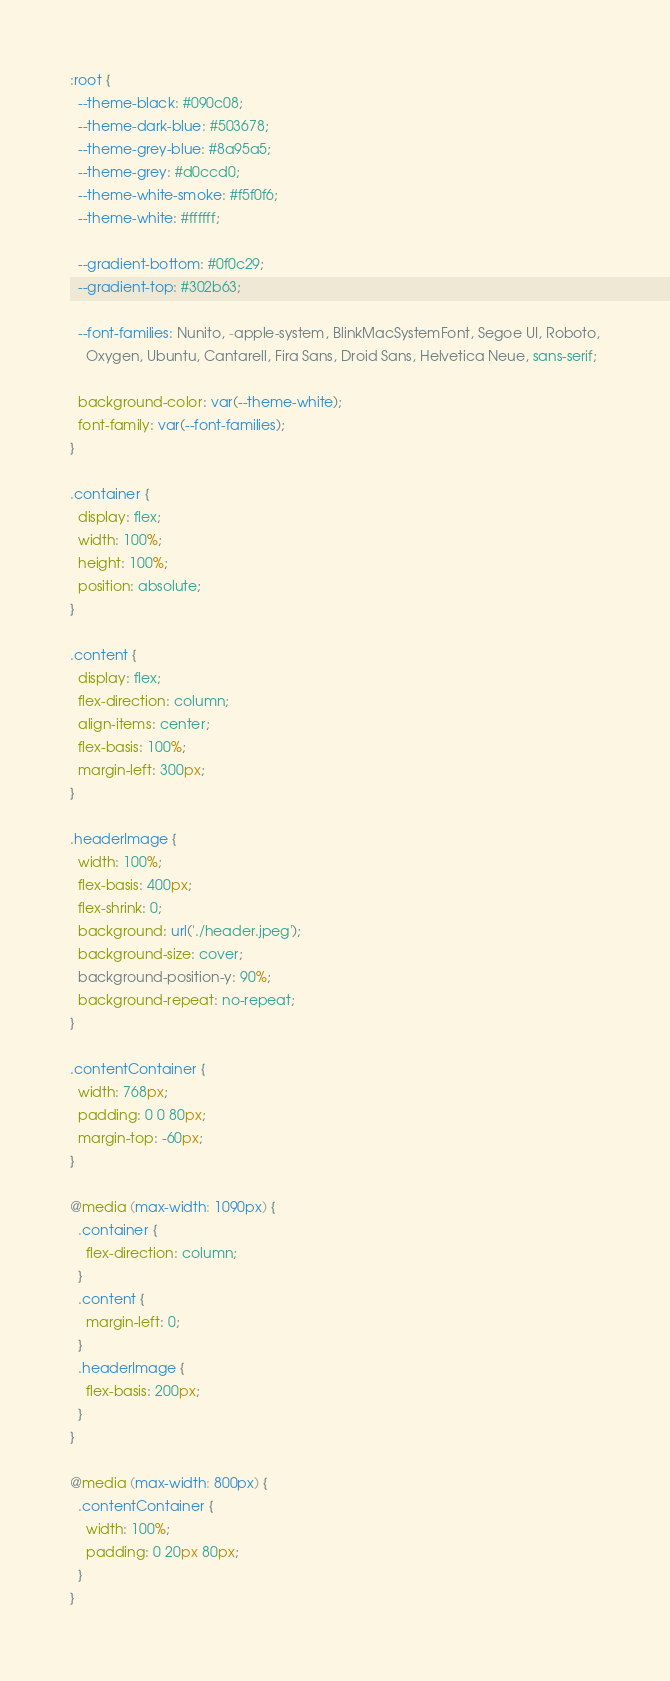Convert code to text. <code><loc_0><loc_0><loc_500><loc_500><_CSS_>:root {
  --theme-black: #090c08;
  --theme-dark-blue: #503678;
  --theme-grey-blue: #8a95a5;
  --theme-grey: #d0ccd0;
  --theme-white-smoke: #f5f0f6;
  --theme-white: #ffffff;

  --gradient-bottom: #0f0c29;
  --gradient-top: #302b63;

  --font-families: Nunito, -apple-system, BlinkMacSystemFont, Segoe UI, Roboto,
    Oxygen, Ubuntu, Cantarell, Fira Sans, Droid Sans, Helvetica Neue, sans-serif;

  background-color: var(--theme-white);
  font-family: var(--font-families);
}

.container {
  display: flex;
  width: 100%;
  height: 100%;
  position: absolute;
}

.content {
  display: flex;
  flex-direction: column;
  align-items: center;
  flex-basis: 100%;
  margin-left: 300px;
}

.headerImage {
  width: 100%;
  flex-basis: 400px;
  flex-shrink: 0;
  background: url('./header.jpeg');
  background-size: cover;
  background-position-y: 90%;
  background-repeat: no-repeat;
}

.contentContainer {
  width: 768px;
  padding: 0 0 80px;
  margin-top: -60px;
}

@media (max-width: 1090px) {
  .container {
    flex-direction: column;
  }
  .content {
    margin-left: 0;
  }
  .headerImage {
    flex-basis: 200px;
  }
}

@media (max-width: 800px) {
  .contentContainer {
    width: 100%;
    padding: 0 20px 80px;
  }
}
</code> 